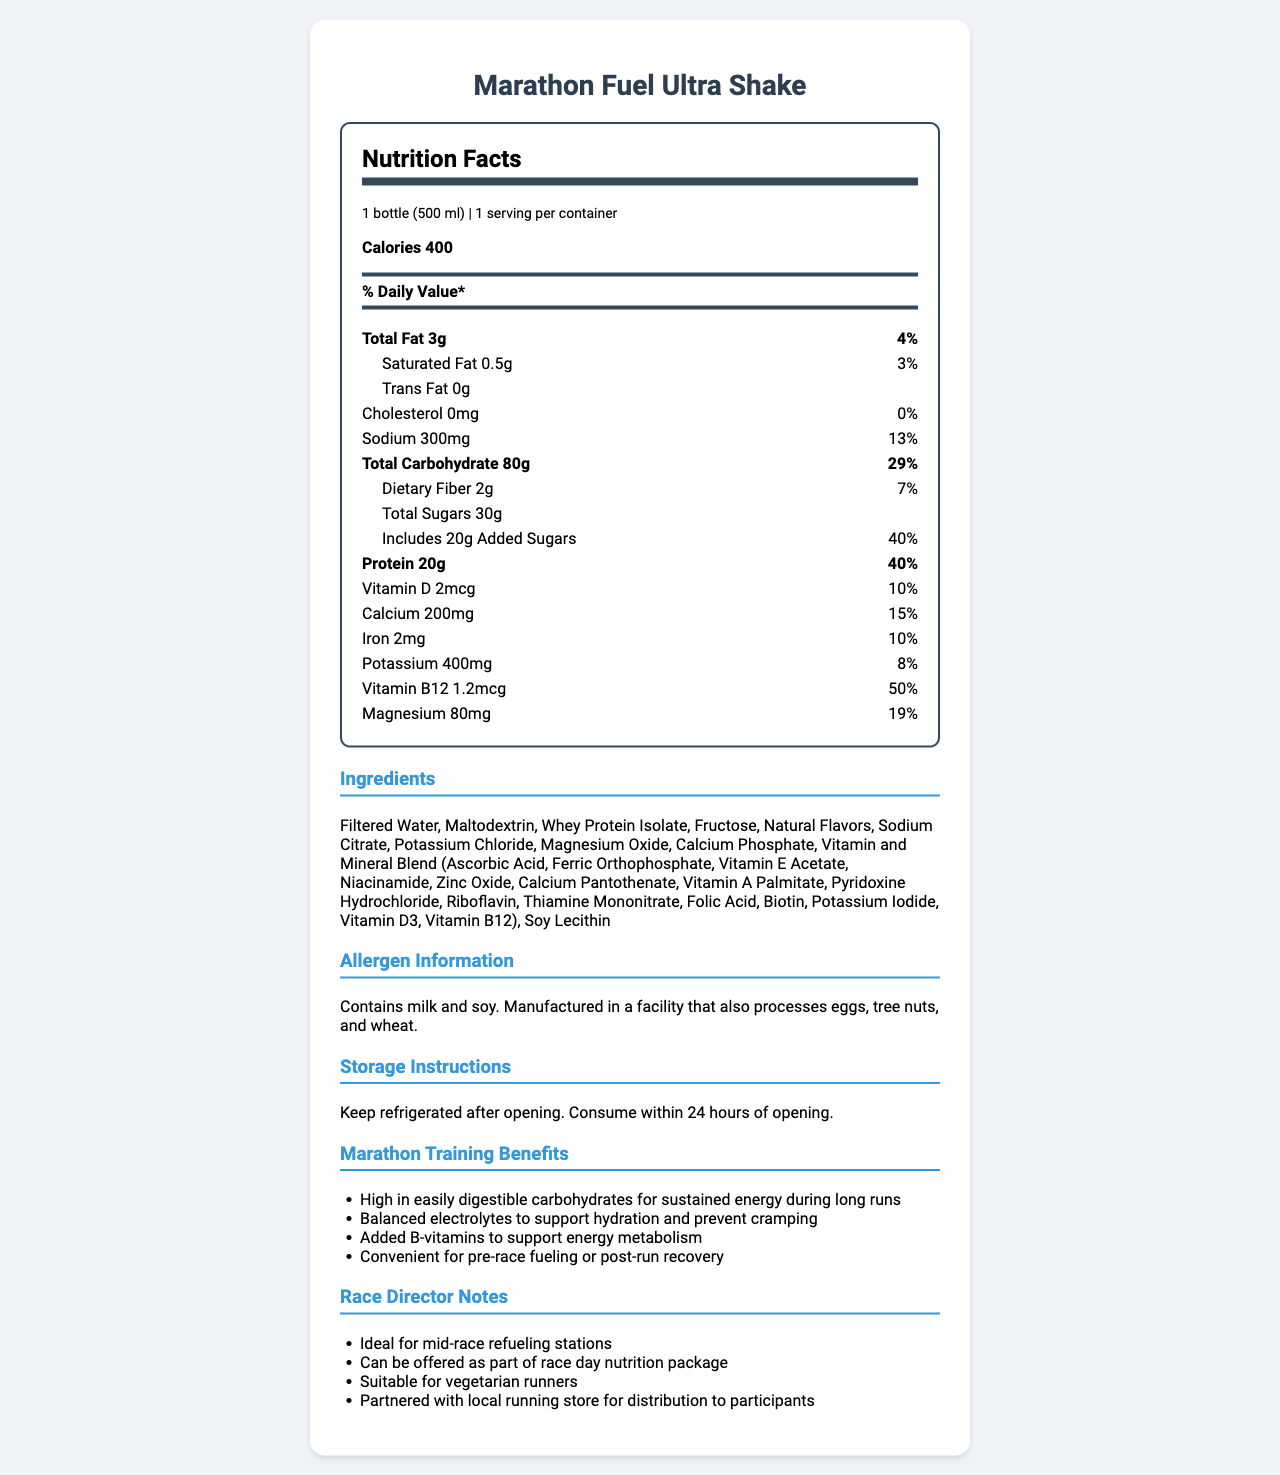who is the product designed for? The product name and the marathon training benefits section indicate that the shake is designed for marathon runners.
Answer: Marathon runners how many calories are in one serving? The nutrition facts section lists 400 calories per serving.
Answer: 400 calories what is the serving size of the Marathon Fuel Ultra Shake? The serving size information is given in the nutrition facts label.
Answer: 1 bottle (500 ml) what percentage of daily value is the added sugars? The nutrition facts label specifies that the added sugars constitute 40% of the daily value.
Answer: 40% how much protein is in one serving of the shake? The nutrition facts label shows that one serving contains 20g of protein.
Answer: 20g which vitamin has the highest daily value percentage? The nutrition facts section indicates that vitamin B12 has a daily value percentage of 50%.
Answer: Vitamin B12 what is the main source of carbohydrates in the ingredients list? A. Whey Protein Isolate B. Fructose C. Maltodextrin D. Sodium Citrate Maltodextrin is listed as one of the main ingredients and is a common source of carbohydrates.
Answer: C which of the following nutrients does the shake have zero amount of? A. Trans Fat B. Sodium C. Cholesterol D. Both A and C The nutrition facts indicate that the shake contains zero trans fat and zero cholesterol.
Answer: D is this shake suitable for someone with a soy allergy? The allergen information states that the shake contains soy.
Answer: No describe the main idea of this nutrition facts label. The document provides detailed nutrition facts, ingredient information, allergen warnings, storage instructions, benefits for marathon training, and notes for race directors.
Answer: The Marathon Fuel Ultra Shake is a carbohydrate-rich meal replacement shake designed for marathon training, featuring high-calorie content, balanced electrolytes, significant protein, and essential vitamins and minerals specially formulated for runners. how long can the shake be consumed after opening if kept refrigerated? The storage instructions mention that the shake should be consumed within 24 hours of opening if kept refrigerated.
Answer: Within 24 hours how many servings are there per container? The nutrition facts label shows that there is 1 serving per container.
Answer: 1 serving what is the percentage daily value of dietary fiber? The nutrition facts label lists the dietary fiber as 2g, which is 7% of the daily value.
Answer: 7% can this shake be used as part of a race day nutrition package? One of the race director notes explicitly states that the shake can be offered as part of a race day nutrition package.
Answer: Yes is there any information on the product's flavor profile? The document does not provide specific details about the flavor profile of the shake.
Answer: Not enough information which of these is part of the vitamin and mineral blend in the ingredients list? A. Calcium Phosphate B. Sodium Citrate C. Riboflavin D. Whey Protein Isolate Riboflavin is part of the vitamin and mineral blend as listed in the ingredients section.
Answer: C 